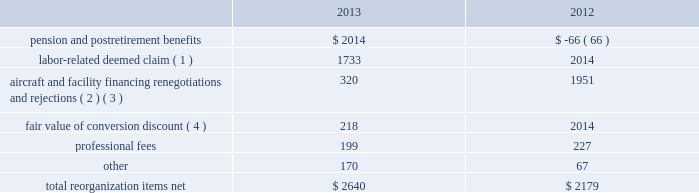Table of contents interest expense , net of capitalized interest increased $ 64 million , or 9.8% ( 9.8 % ) , to $ 710 million in 2013 from $ 646 million in 2012 primarily due to special charges of $ 92 million to recognize post-petition interest expense on unsecured obligations pursuant to the plan and penalty interest related to 10.5% ( 10.5 % ) secured notes and 7.50% ( 7.50 % ) senior secured notes .
Other nonoperating expense , net of $ 84 million in 2013 consists principally of net foreign currency losses of $ 55 million and early debt extinguishment charges of $ 48 million .
Other nonoperating income in 2012 consisted principally of a $ 280 million special credit related to the settlement of a commercial dispute partially offset by net foreign currency losses .
Reorganization items , net reorganization items refer to revenues , expenses ( including professional fees ) , realized gains and losses and provisions for losses that are realized or incurred as a direct result of the chapter 11 cases .
The table summarizes the components included in reorganization items , net on american 2019s consolidated statements of operations for the years ended december 31 , 2013 and 2012 ( in millions ) : .
( 1 ) in exchange for employees 2019 contributions to the successful reorganization , including agreeing to reductions in pay and benefits , american agreed in the plan to provide each employee group a deemed claim , which was used to provide a distribution of a portion of the equity of the reorganized entity to those employees .
Each employee group received a deemed claim amount based upon a portion of the value of cost savings provided by that group through reductions to pay and benefits as well as through certain work rule changes .
The total value of this deemed claim was approximately $ 1.7 billion .
( 2 ) amounts include allowed claims ( claims approved by the bankruptcy court ) and estimated allowed claims relating to ( i ) the rejection or modification of financings related to aircraft and ( ii ) entry of orders treated as unsecured claims with respect to facility agreements supporting certain issuances of special facility revenue bonds .
The debtors recorded an estimated claim associated with the rejection or modification of a financing or facility agreement when the applicable motion was filed with the bankruptcy court to reject or modify such financing or facility agreement and the debtors believed that it was probable the motion would be approved , and there was sufficient information to estimate the claim .
See note 2 to american 2019s consolidated financial statements in part ii , item 8b for further information .
( 3 ) pursuant to the plan , the debtors agreed to allow certain post-petition unsecured claims on obligations .
As a result , during the year ended december 31 , 2013 , american recorded reorganization charges to adjust estimated allowed claim amounts previously recorded on rejected special facility revenue bonds of $ 180 million , allowed general unsecured claims related to the 1990 and 1994 series of special facility revenue bonds that financed certain improvements at jfk , and rejected bonds that financed certain improvements at ord , which are included in the table above .
( 4 ) the plan allowed unsecured creditors receiving aag series a preferred stock a conversion discount of 3.5% ( 3.5 % ) .
Accordingly , american recorded the fair value of such discount upon the confirmation of the plan by the bankruptcy court. .
By how much did aircraft and facility financing renegotiations and rejections decrease from 2012 to 2013? 
Computations: ((320 - 1951) / 1951)
Answer: -0.83598. Table of contents interest expense , net of capitalized interest increased $ 64 million , or 9.8% ( 9.8 % ) , to $ 710 million in 2013 from $ 646 million in 2012 primarily due to special charges of $ 92 million to recognize post-petition interest expense on unsecured obligations pursuant to the plan and penalty interest related to 10.5% ( 10.5 % ) secured notes and 7.50% ( 7.50 % ) senior secured notes .
Other nonoperating expense , net of $ 84 million in 2013 consists principally of net foreign currency losses of $ 55 million and early debt extinguishment charges of $ 48 million .
Other nonoperating income in 2012 consisted principally of a $ 280 million special credit related to the settlement of a commercial dispute partially offset by net foreign currency losses .
Reorganization items , net reorganization items refer to revenues , expenses ( including professional fees ) , realized gains and losses and provisions for losses that are realized or incurred as a direct result of the chapter 11 cases .
The table summarizes the components included in reorganization items , net on american 2019s consolidated statements of operations for the years ended december 31 , 2013 and 2012 ( in millions ) : .
( 1 ) in exchange for employees 2019 contributions to the successful reorganization , including agreeing to reductions in pay and benefits , american agreed in the plan to provide each employee group a deemed claim , which was used to provide a distribution of a portion of the equity of the reorganized entity to those employees .
Each employee group received a deemed claim amount based upon a portion of the value of cost savings provided by that group through reductions to pay and benefits as well as through certain work rule changes .
The total value of this deemed claim was approximately $ 1.7 billion .
( 2 ) amounts include allowed claims ( claims approved by the bankruptcy court ) and estimated allowed claims relating to ( i ) the rejection or modification of financings related to aircraft and ( ii ) entry of orders treated as unsecured claims with respect to facility agreements supporting certain issuances of special facility revenue bonds .
The debtors recorded an estimated claim associated with the rejection or modification of a financing or facility agreement when the applicable motion was filed with the bankruptcy court to reject or modify such financing or facility agreement and the debtors believed that it was probable the motion would be approved , and there was sufficient information to estimate the claim .
See note 2 to american 2019s consolidated financial statements in part ii , item 8b for further information .
( 3 ) pursuant to the plan , the debtors agreed to allow certain post-petition unsecured claims on obligations .
As a result , during the year ended december 31 , 2013 , american recorded reorganization charges to adjust estimated allowed claim amounts previously recorded on rejected special facility revenue bonds of $ 180 million , allowed general unsecured claims related to the 1990 and 1994 series of special facility revenue bonds that financed certain improvements at jfk , and rejected bonds that financed certain improvements at ord , which are included in the table above .
( 4 ) the plan allowed unsecured creditors receiving aag series a preferred stock a conversion discount of 3.5% ( 3.5 % ) .
Accordingly , american recorded the fair value of such discount upon the confirmation of the plan by the bankruptcy court. .
What was the percentage growth in the total re-organization costs from 2012 to 2013? 
Rationale: the percent is the most recent amount less the prior amount divided by the prior amount multiply by 100
Computations: ((2640 - 2179) / 2179)
Answer: 0.21156. Table of contents interest expense , net of capitalized interest increased $ 64 million , or 9.8% ( 9.8 % ) , to $ 710 million in 2013 from $ 646 million in 2012 primarily due to special charges of $ 92 million to recognize post-petition interest expense on unsecured obligations pursuant to the plan and penalty interest related to 10.5% ( 10.5 % ) secured notes and 7.50% ( 7.50 % ) senior secured notes .
Other nonoperating expense , net of $ 84 million in 2013 consists principally of net foreign currency losses of $ 55 million and early debt extinguishment charges of $ 48 million .
Other nonoperating income in 2012 consisted principally of a $ 280 million special credit related to the settlement of a commercial dispute partially offset by net foreign currency losses .
Reorganization items , net reorganization items refer to revenues , expenses ( including professional fees ) , realized gains and losses and provisions for losses that are realized or incurred as a direct result of the chapter 11 cases .
The table summarizes the components included in reorganization items , net on american 2019s consolidated statements of operations for the years ended december 31 , 2013 and 2012 ( in millions ) : .
( 1 ) in exchange for employees 2019 contributions to the successful reorganization , including agreeing to reductions in pay and benefits , american agreed in the plan to provide each employee group a deemed claim , which was used to provide a distribution of a portion of the equity of the reorganized entity to those employees .
Each employee group received a deemed claim amount based upon a portion of the value of cost savings provided by that group through reductions to pay and benefits as well as through certain work rule changes .
The total value of this deemed claim was approximately $ 1.7 billion .
( 2 ) amounts include allowed claims ( claims approved by the bankruptcy court ) and estimated allowed claims relating to ( i ) the rejection or modification of financings related to aircraft and ( ii ) entry of orders treated as unsecured claims with respect to facility agreements supporting certain issuances of special facility revenue bonds .
The debtors recorded an estimated claim associated with the rejection or modification of a financing or facility agreement when the applicable motion was filed with the bankruptcy court to reject or modify such financing or facility agreement and the debtors believed that it was probable the motion would be approved , and there was sufficient information to estimate the claim .
See note 2 to american 2019s consolidated financial statements in part ii , item 8b for further information .
( 3 ) pursuant to the plan , the debtors agreed to allow certain post-petition unsecured claims on obligations .
As a result , during the year ended december 31 , 2013 , american recorded reorganization charges to adjust estimated allowed claim amounts previously recorded on rejected special facility revenue bonds of $ 180 million , allowed general unsecured claims related to the 1990 and 1994 series of special facility revenue bonds that financed certain improvements at jfk , and rejected bonds that financed certain improvements at ord , which are included in the table above .
( 4 ) the plan allowed unsecured creditors receiving aag series a preferred stock a conversion discount of 3.5% ( 3.5 % ) .
Accordingly , american recorded the fair value of such discount upon the confirmation of the plan by the bankruptcy court. .
In 2013 what was the ratio of the interest expense , net of capitalized interest to the other non operating income net related to debt extinguishm net and currency losses? 
Rationale: there was $ 8.45 for every $ 1 of other other non operating income net related to debt extinguish net and foreign currency losses
Computations: (710 / 84)
Answer: 8.45238. 